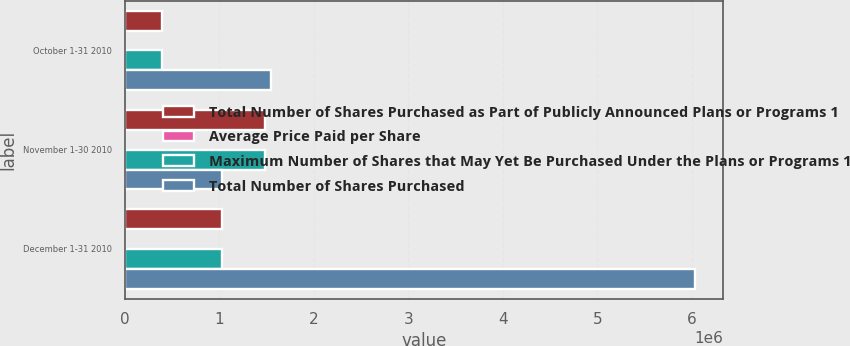<chart> <loc_0><loc_0><loc_500><loc_500><stacked_bar_chart><ecel><fcel>October 1-31 2010<fcel>November 1-30 2010<fcel>December 1-31 2010<nl><fcel>Total Number of Shares Purchased as Part of Publicly Announced Plans or Programs 1<fcel>393885<fcel>1.48608e+06<fcel>1.027e+06<nl><fcel>Average Price Paid per Share<fcel>54.44<fcel>55.31<fcel>58.79<nl><fcel>Maximum Number of Shares that May Yet Be Purchased Under the Plans or Programs 1<fcel>393885<fcel>1.48608e+06<fcel>1.027e+06<nl><fcel>Total Number of Shares Purchased<fcel>1.54434e+06<fcel>1.027e+06<fcel>6.03126e+06<nl></chart> 